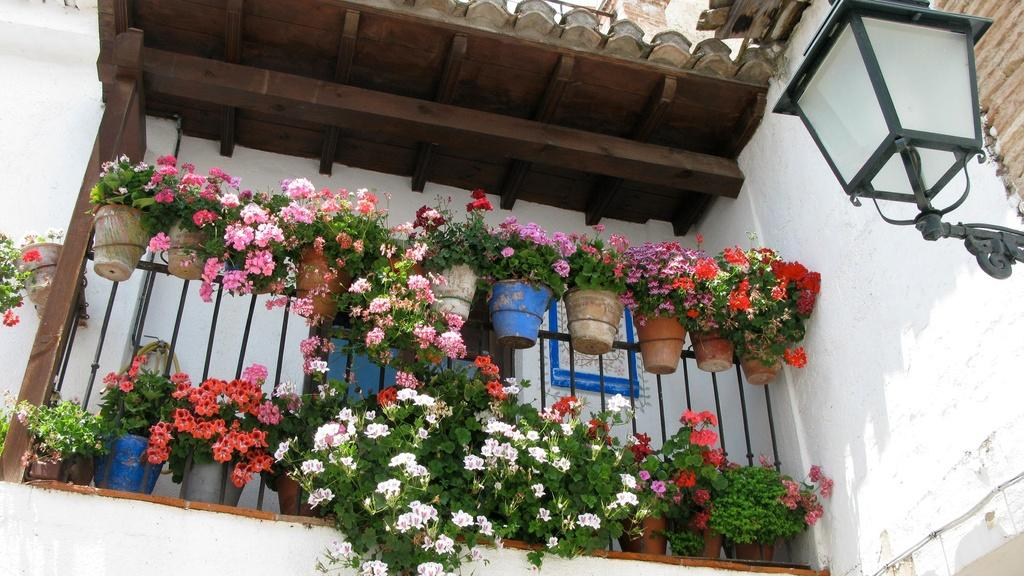What type of structure is visible in the image? There is a building in the image. What are the main components of the building? The building has a roof and walls. What other object can be seen in the image? There is a street lamp in the image. What type of vegetation is present in the image? There are plants with flowers in a pot. Where are the plants with flowers located? The plants with flowers are kept on the railing. What type of cracker is being eaten by the writer in the image? There is no writer or cracker present in the image. Can you tell me how many ants are crawling on the plants with flowers in the image? There are no ants visible on the plants with flowers in the image. 